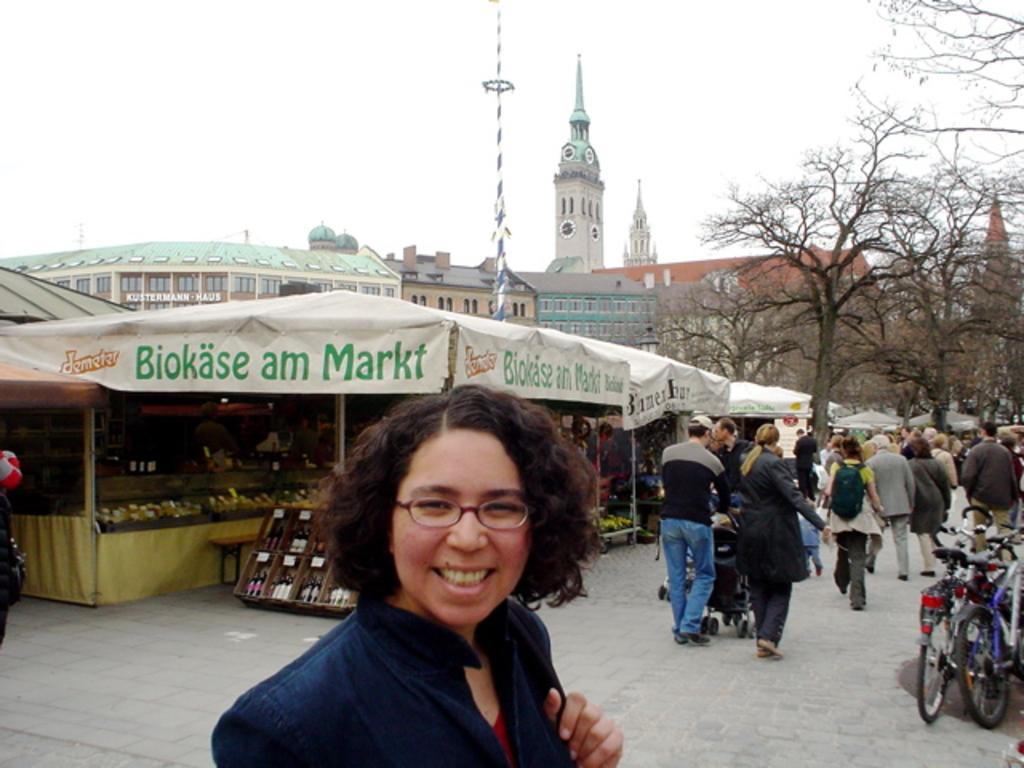Please provide a concise description of this image. As we can see in the image there are group of people, wheel chair, bicycle, tent, banners, trees, buildings and at the top there is sky. The woman standing in the front is wearing blue color dress. 